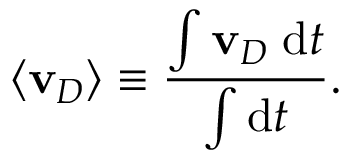Convert formula to latex. <formula><loc_0><loc_0><loc_500><loc_500>\langle v _ { D } \rangle \equiv \frac { \int v _ { D } \, d t } { \int d t } .</formula> 